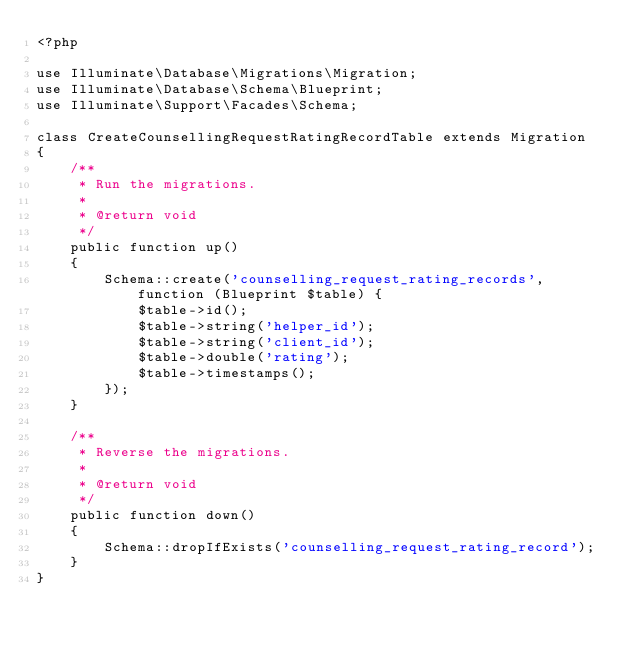Convert code to text. <code><loc_0><loc_0><loc_500><loc_500><_PHP_><?php

use Illuminate\Database\Migrations\Migration;
use Illuminate\Database\Schema\Blueprint;
use Illuminate\Support\Facades\Schema;

class CreateCounsellingRequestRatingRecordTable extends Migration
{
    /**
     * Run the migrations.
     *
     * @return void
     */
    public function up()
    {
        Schema::create('counselling_request_rating_records', function (Blueprint $table) {
            $table->id();
            $table->string('helper_id');
            $table->string('client_id');
            $table->double('rating');
            $table->timestamps();
        });
    }

    /**
     * Reverse the migrations.
     *
     * @return void
     */
    public function down()
    {
        Schema::dropIfExists('counselling_request_rating_record');
    }
}
</code> 